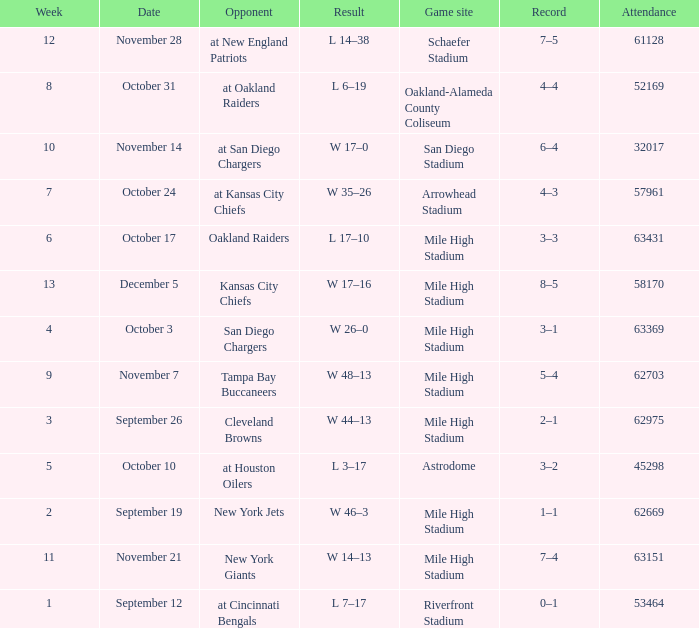What was the week number when the opponent was the New York Jets? 2.0. 